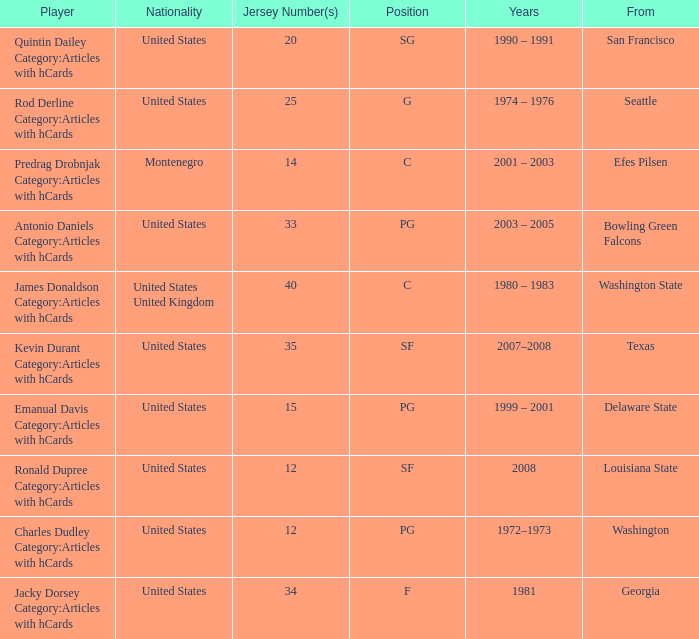Help me parse the entirety of this table. {'header': ['Player', 'Nationality', 'Jersey Number(s)', 'Position', 'Years', 'From'], 'rows': [['Quintin Dailey Category:Articles with hCards', 'United States', '20', 'SG', '1990 – 1991', 'San Francisco'], ['Rod Derline Category:Articles with hCards', 'United States', '25', 'G', '1974 – 1976', 'Seattle'], ['Predrag Drobnjak Category:Articles with hCards', 'Montenegro', '14', 'C', '2001 – 2003', 'Efes Pilsen'], ['Antonio Daniels Category:Articles with hCards', 'United States', '33', 'PG', '2003 – 2005', 'Bowling Green Falcons'], ['James Donaldson Category:Articles with hCards', 'United States United Kingdom', '40', 'C', '1980 – 1983', 'Washington State'], ['Kevin Durant Category:Articles with hCards', 'United States', '35', 'SF', '2007–2008', 'Texas'], ['Emanual Davis Category:Articles with hCards', 'United States', '15', 'PG', '1999 – 2001', 'Delaware State'], ['Ronald Dupree Category:Articles with hCards', 'United States', '12', 'SF', '2008', 'Louisiana State'], ['Charles Dudley Category:Articles with hCards', 'United States', '12', 'PG', '1972–1973', 'Washington'], ['Jacky Dorsey Category:Articles with hCards', 'United States', '34', 'F', '1981', 'Georgia']]} What was the nationality of the players with a position of g? United States. 